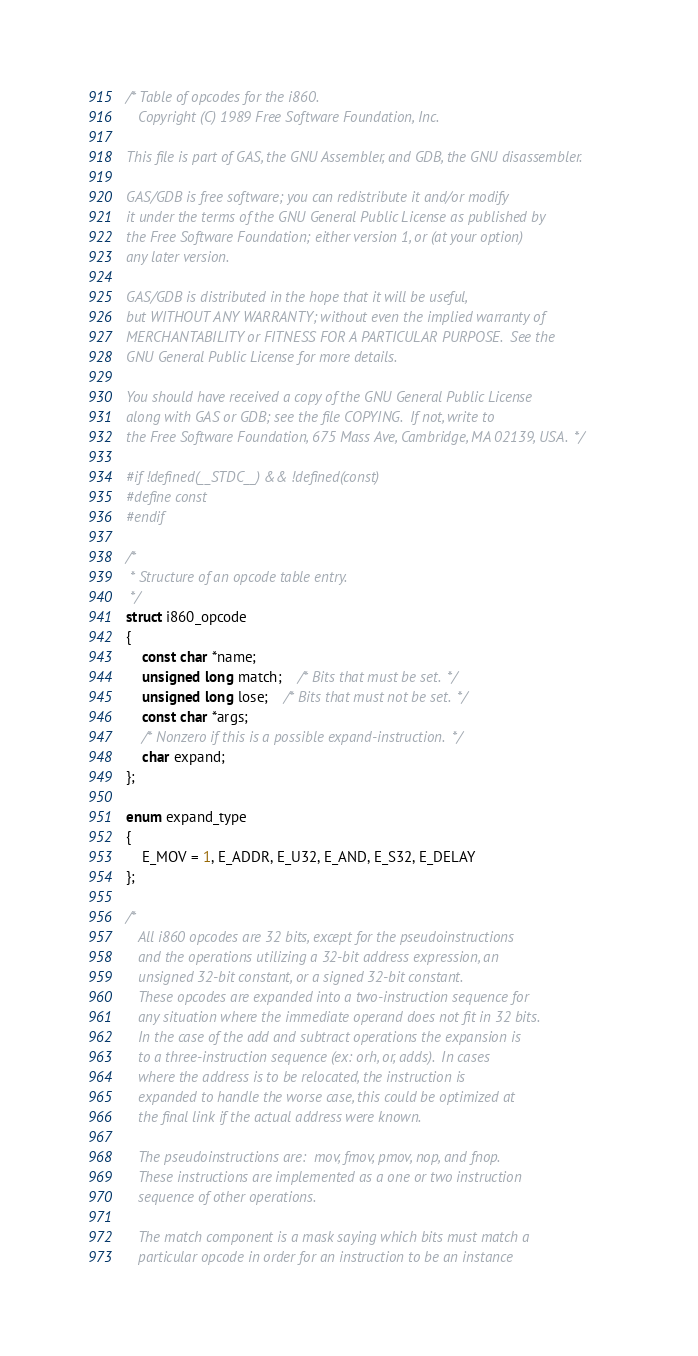<code> <loc_0><loc_0><loc_500><loc_500><_C_>/* Table of opcodes for the i860.
   Copyright (C) 1989 Free Software Foundation, Inc.

This file is part of GAS, the GNU Assembler, and GDB, the GNU disassembler.

GAS/GDB is free software; you can redistribute it and/or modify
it under the terms of the GNU General Public License as published by
the Free Software Foundation; either version 1, or (at your option)
any later version.

GAS/GDB is distributed in the hope that it will be useful,
but WITHOUT ANY WARRANTY; without even the implied warranty of
MERCHANTABILITY or FITNESS FOR A PARTICULAR PURPOSE.  See the
GNU General Public License for more details.

You should have received a copy of the GNU General Public License
along with GAS or GDB; see the file COPYING.  If not, write to
the Free Software Foundation, 675 Mass Ave, Cambridge, MA 02139, USA.  */

#if !defined(__STDC__) && !defined(const)
#define const
#endif

/*
 * Structure of an opcode table entry.
 */
struct i860_opcode
{
    const char *name;
    unsigned long match;	/* Bits that must be set.  */
    unsigned long lose;	/* Bits that must not be set.  */
    const char *args;
    /* Nonzero if this is a possible expand-instruction.  */
    char expand;
};

enum expand_type
{
    E_MOV = 1, E_ADDR, E_U32, E_AND, E_S32, E_DELAY
};

/*
   All i860 opcodes are 32 bits, except for the pseudoinstructions
   and the operations utilizing a 32-bit address expression, an
   unsigned 32-bit constant, or a signed 32-bit constant.
   These opcodes are expanded into a two-instruction sequence for
   any situation where the immediate operand does not fit in 32 bits.
   In the case of the add and subtract operations the expansion is
   to a three-instruction sequence (ex: orh, or, adds).  In cases
   where the address is to be relocated, the instruction is
   expanded to handle the worse case, this could be optimized at
   the final link if the actual address were known.

   The pseudoinstructions are:  mov, fmov, pmov, nop, and fnop.
   These instructions are implemented as a one or two instruction
   sequence of other operations.

   The match component is a mask saying which bits must match a
   particular opcode in order for an instruction to be an instance</code> 